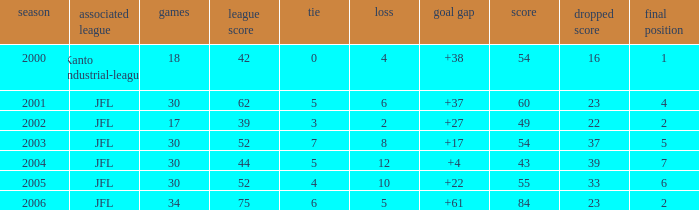Tell me the highest matches for point 43 and final rank less than 7 None. 